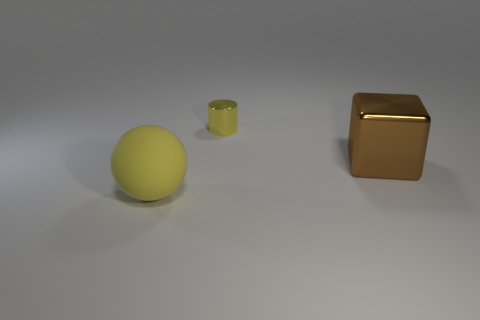Add 3 gray spheres. How many objects exist? 6 Subtract 0 purple balls. How many objects are left? 3 Subtract all blocks. How many objects are left? 2 Subtract all gray spheres. Subtract all cubes. How many objects are left? 2 Add 1 yellow cylinders. How many yellow cylinders are left? 2 Add 3 small cylinders. How many small cylinders exist? 4 